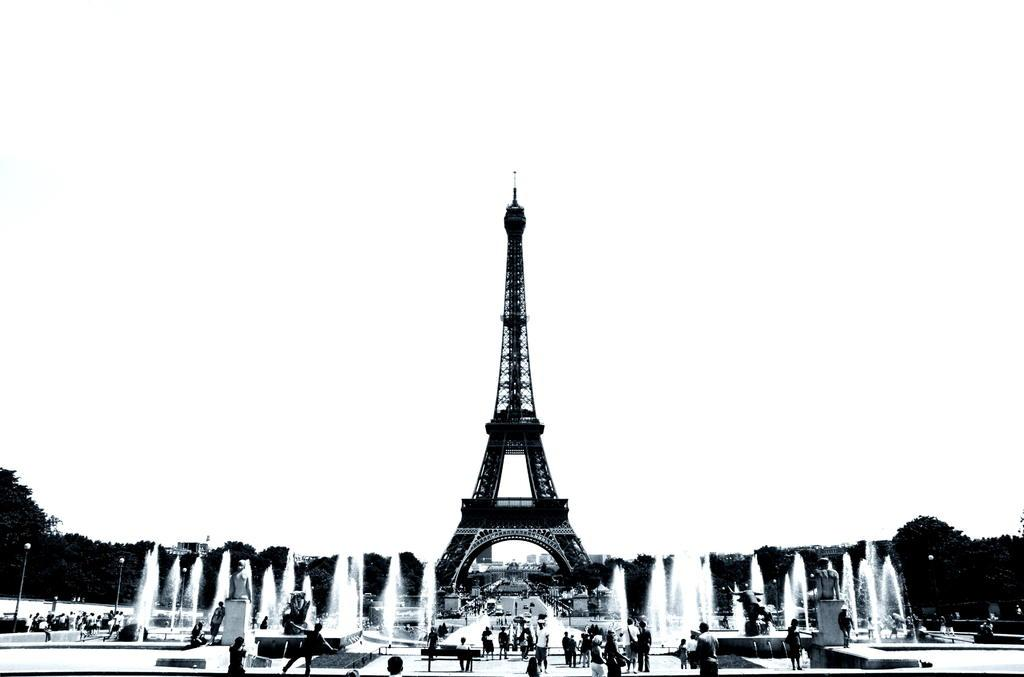Who or what can be seen in the image? There are people in the image. What architectural feature is present in the center of the image? The Eiffel Tower is present in the center of the image. What type of structures are visible in the image? There are fountains and poles in the image. What natural elements can be seen in the image? There are trees in the image. How is the image presented in terms of color? The image is black and white. What type of ray is visible in the image? There is no ray present in the image. Can you see a whip being used in the image? There is no whip present in the image. 